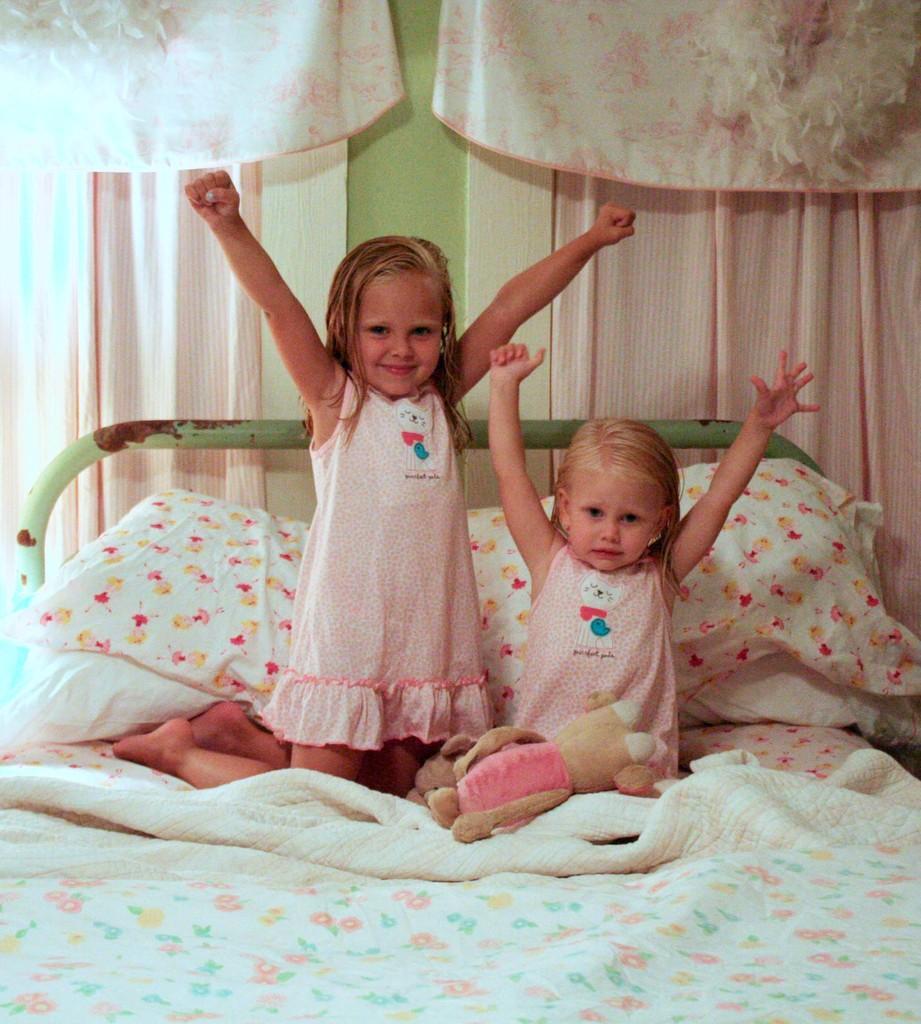How would you summarize this image in a sentence or two? At the bottom of the image there is bed, on the bed two girls are sitting and smiling. At the top of the image there is wall, on the wall there is curtain. 